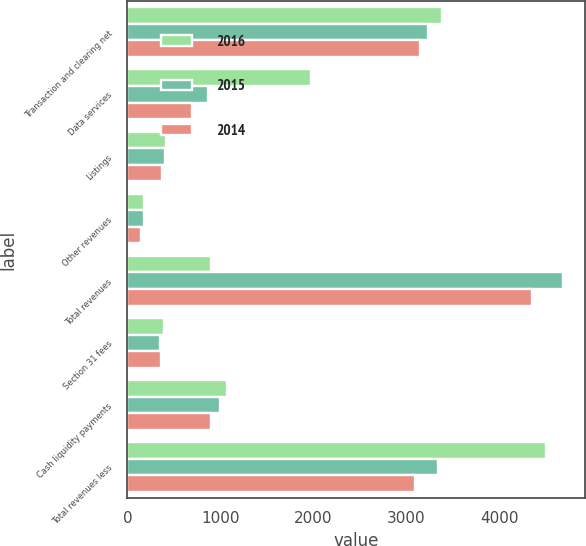Convert chart. <chart><loc_0><loc_0><loc_500><loc_500><stacked_bar_chart><ecel><fcel>Transaction and clearing net<fcel>Data services<fcel>Listings<fcel>Other revenues<fcel>Total revenues<fcel>Section 31 fees<fcel>Cash liquidity payments<fcel>Total revenues less<nl><fcel>2016<fcel>3384<fcel>1978<fcel>419<fcel>177<fcel>901<fcel>389<fcel>1070<fcel>4499<nl><fcel>2015<fcel>3228<fcel>871<fcel>405<fcel>178<fcel>4682<fcel>349<fcel>995<fcel>3338<nl><fcel>2014<fcel>3144<fcel>691<fcel>367<fcel>150<fcel>4352<fcel>359<fcel>901<fcel>3092<nl></chart> 